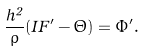Convert formula to latex. <formula><loc_0><loc_0><loc_500><loc_500>\frac { h ^ { 2 } } { \rho } ( I F ^ { \prime } - \Theta ) = \Phi ^ { \prime } .</formula> 